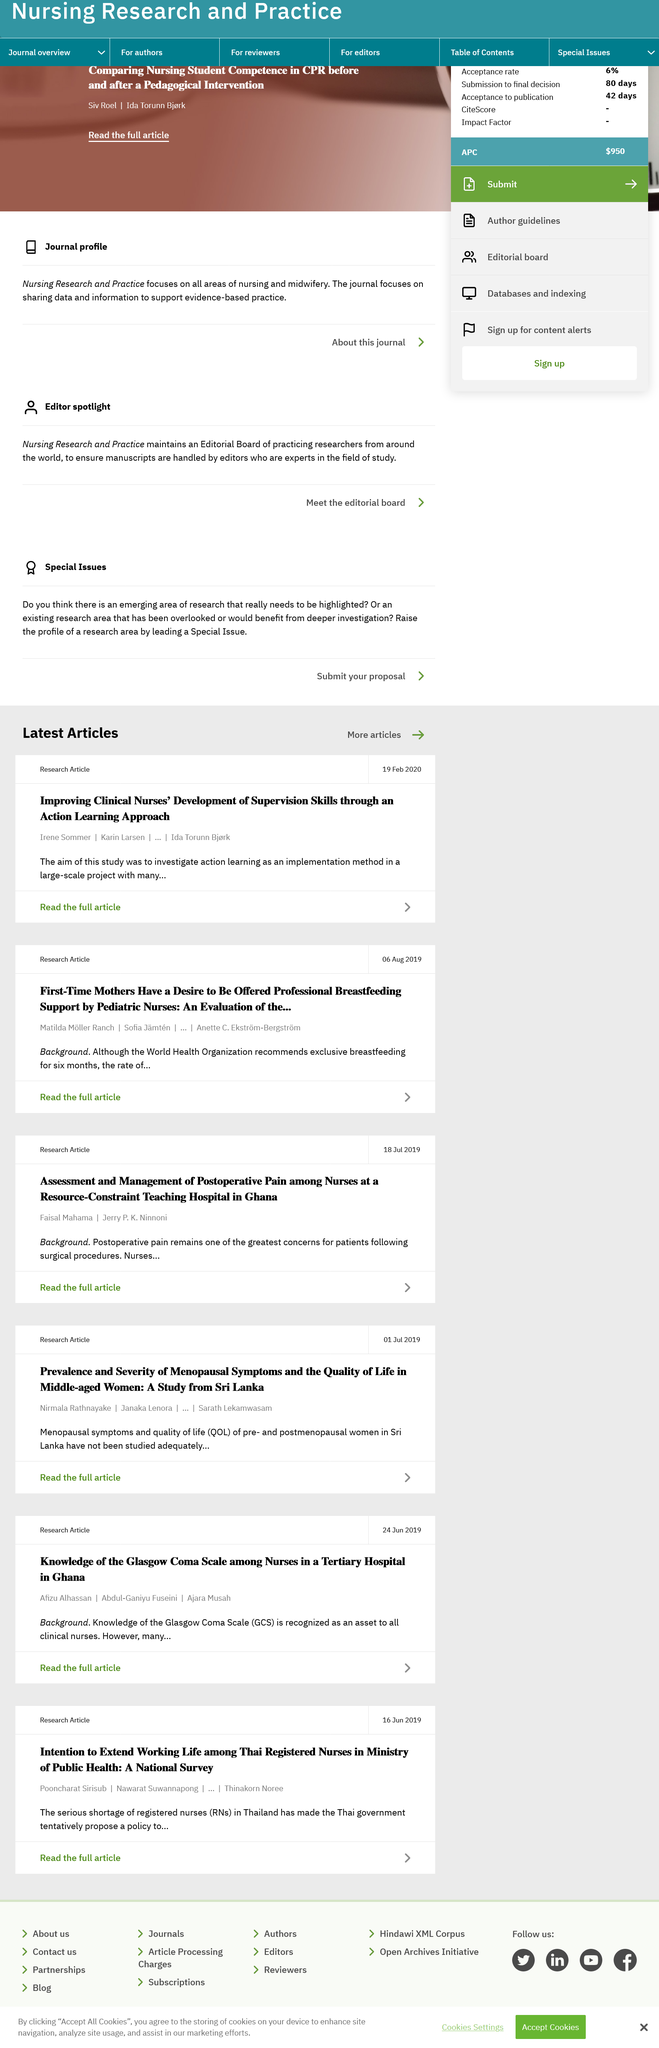Highlight a few significant elements in this photo. The article in question explores the challenges and management of postoperative pain among nurses at resource-constrained teaching hospitals. The approach being used to enhance nurses' proficiency in supervision skills is an action learning method. The research hospital is located in Ghana. The surname of the author named Irene is Sommer. The date on the research article is July 18, 2019. 